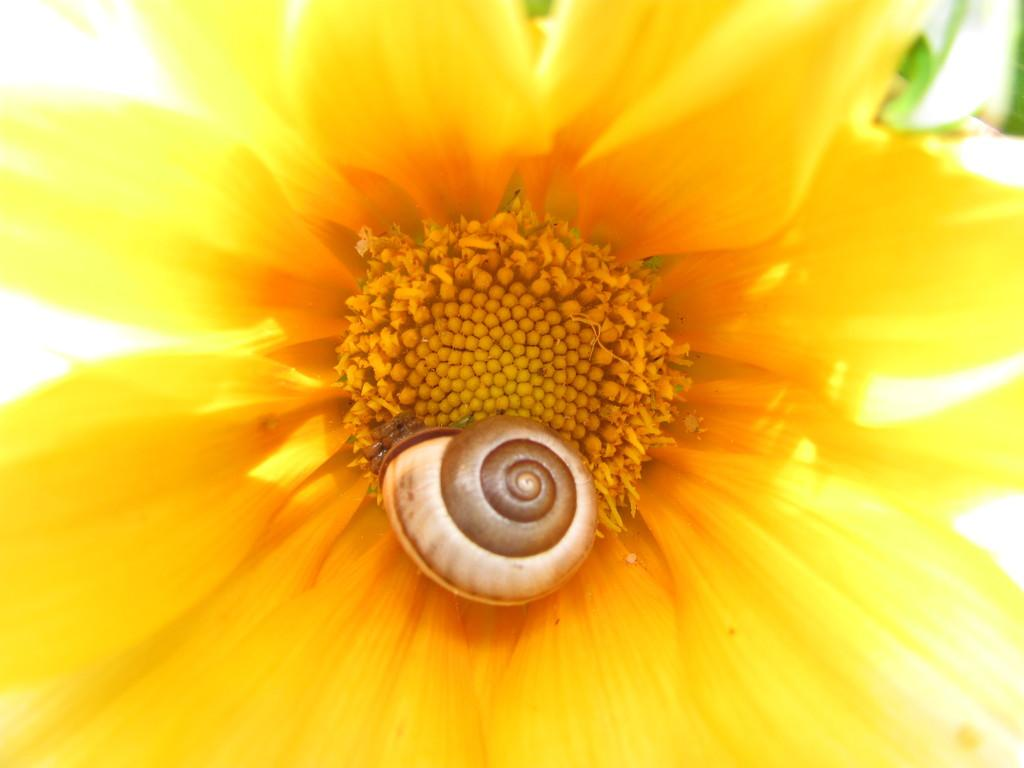What is the main subject of the image? The main subject of the image is a zoom-in picture of a flower. Are there any other objects or elements in the image? Yes, there is a sea snail shell in the middle of the image. What type of cast can be seen on the flower in the image? There is no cast present on the flower in the image. What place does the tramp live in the image? There is no tramp or any living being in the image; it only contains a flower and a sea snail shell. 